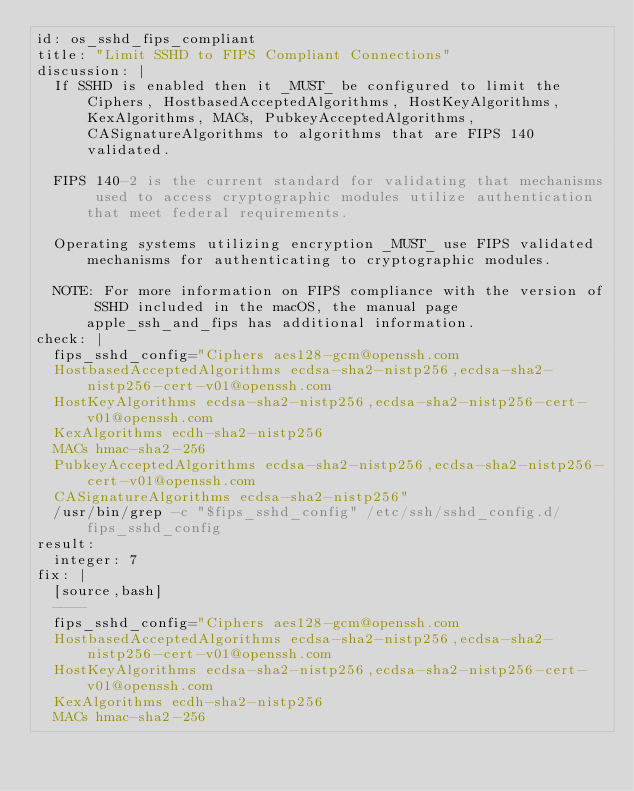Convert code to text. <code><loc_0><loc_0><loc_500><loc_500><_YAML_>id: os_sshd_fips_compliant
title: "Limit SSHD to FIPS Compliant Connections"
discussion: |
  If SSHD is enabled then it _MUST_ be configured to limit the Ciphers, HostbasedAcceptedAlgorithms, HostKeyAlgorithms, KexAlgorithms, MACs, PubkeyAcceptedAlgorithms, CASignatureAlgorithms to algorithms that are FIPS 140 validated.

  FIPS 140-2 is the current standard for validating that mechanisms used to access cryptographic modules utilize authentication that meet federal requirements.

  Operating systems utilizing encryption _MUST_ use FIPS validated mechanisms for authenticating to cryptographic modules. 

  NOTE: For more information on FIPS compliance with the version of SSHD included in the macOS, the manual page apple_ssh_and_fips has additional information.
check: |
  fips_sshd_config="Ciphers aes128-gcm@openssh.com
  HostbasedAcceptedAlgorithms ecdsa-sha2-nistp256,ecdsa-sha2-nistp256-cert-v01@openssh.com
  HostKeyAlgorithms ecdsa-sha2-nistp256,ecdsa-sha2-nistp256-cert-v01@openssh.com
  KexAlgorithms ecdh-sha2-nistp256
  MACs hmac-sha2-256
  PubkeyAcceptedAlgorithms ecdsa-sha2-nistp256,ecdsa-sha2-nistp256-cert-v01@openssh.com
  CASignatureAlgorithms ecdsa-sha2-nistp256"
  /usr/bin/grep -c "$fips_sshd_config" /etc/ssh/sshd_config.d/fips_sshd_config
result:
  integer: 7
fix: |
  [source,bash]
  ----
  fips_sshd_config="Ciphers aes128-gcm@openssh.com
  HostbasedAcceptedAlgorithms ecdsa-sha2-nistp256,ecdsa-sha2-nistp256-cert-v01@openssh.com
  HostKeyAlgorithms ecdsa-sha2-nistp256,ecdsa-sha2-nistp256-cert-v01@openssh.com
  KexAlgorithms ecdh-sha2-nistp256
  MACs hmac-sha2-256</code> 